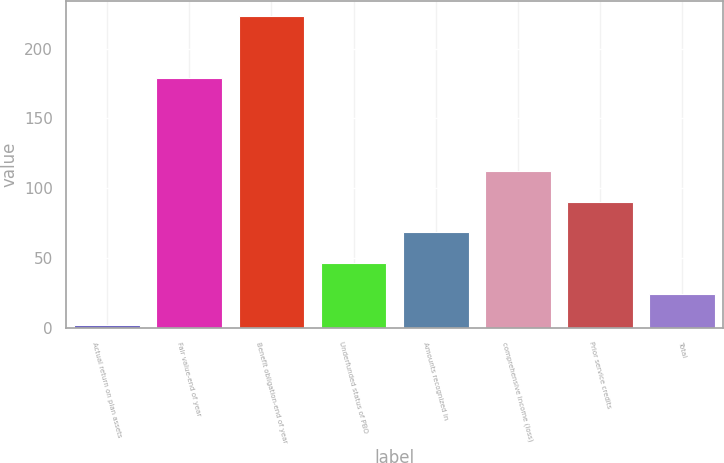<chart> <loc_0><loc_0><loc_500><loc_500><bar_chart><fcel>Actual return on plan assets<fcel>Fair value-end of year<fcel>Benefit obligation-end of year<fcel>Underfunded status of PBO<fcel>Amounts recognized in<fcel>comprehensive income (loss)<fcel>Prior service credits<fcel>Total<nl><fcel>2<fcel>179<fcel>223<fcel>46.2<fcel>68.3<fcel>112.5<fcel>90.4<fcel>24.1<nl></chart> 